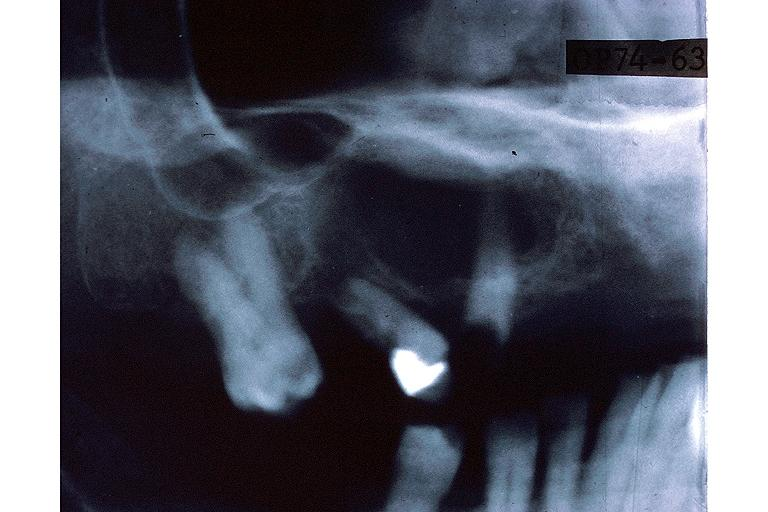s oral present?
Answer the question using a single word or phrase. Yes 